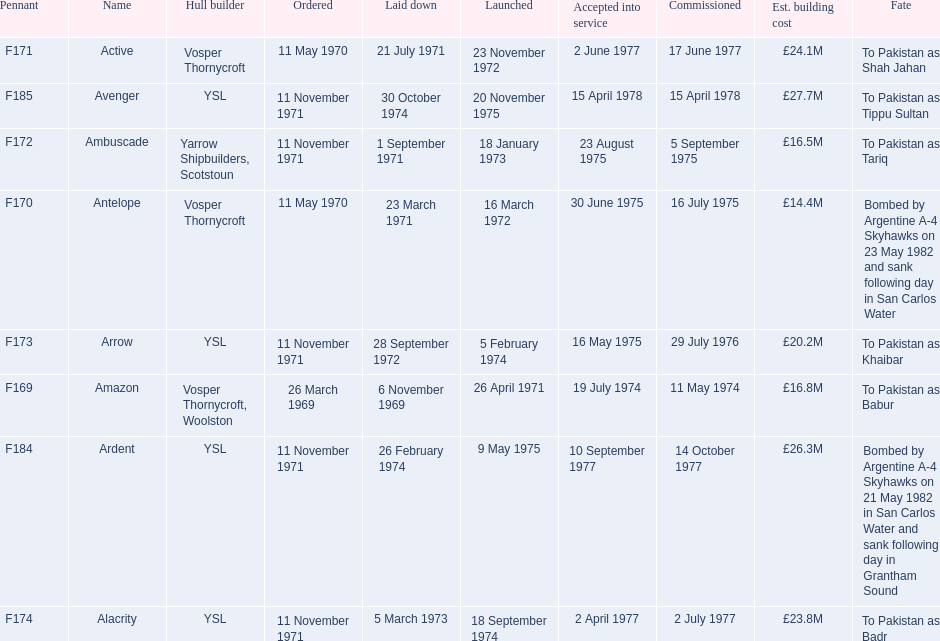Tell me the number of ships that went to pakistan. 6. Write the full table. {'header': ['Pennant', 'Name', 'Hull builder', 'Ordered', 'Laid down', 'Launched', 'Accepted into service', 'Commissioned', 'Est. building cost', 'Fate'], 'rows': [['F171', 'Active', 'Vosper Thornycroft', '11 May 1970', '21 July 1971', '23 November 1972', '2 June 1977', '17 June 1977', '£24.1M', 'To Pakistan as Shah Jahan'], ['F185', 'Avenger', 'YSL', '11 November 1971', '30 October 1974', '20 November 1975', '15 April 1978', '15 April 1978', '£27.7M', 'To Pakistan as Tippu Sultan'], ['F172', 'Ambuscade', 'Yarrow Shipbuilders, Scotstoun', '11 November 1971', '1 September 1971', '18 January 1973', '23 August 1975', '5 September 1975', '£16.5M', 'To Pakistan as Tariq'], ['F170', 'Antelope', 'Vosper Thornycroft', '11 May 1970', '23 March 1971', '16 March 1972', '30 June 1975', '16 July 1975', '£14.4M', 'Bombed by Argentine A-4 Skyhawks on 23 May 1982 and sank following day in San Carlos Water'], ['F173', 'Arrow', 'YSL', '11 November 1971', '28 September 1972', '5 February 1974', '16 May 1975', '29 July 1976', '£20.2M', 'To Pakistan as Khaibar'], ['F169', 'Amazon', 'Vosper Thornycroft, Woolston', '26 March 1969', '6 November 1969', '26 April 1971', '19 July 1974', '11 May 1974', '£16.8M', 'To Pakistan as Babur'], ['F184', 'Ardent', 'YSL', '11 November 1971', '26 February 1974', '9 May 1975', '10 September 1977', '14 October 1977', '£26.3M', 'Bombed by Argentine A-4 Skyhawks on 21 May 1982 in San Carlos Water and sank following day in Grantham Sound'], ['F174', 'Alacrity', 'YSL', '11 November 1971', '5 March 1973', '18 September 1974', '2 April 1977', '2 July 1977', '£23.8M', 'To Pakistan as Badr']]} 